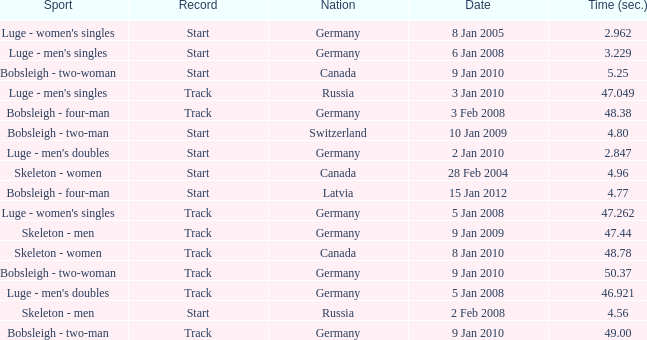Which sport has a time over 49? Bobsleigh - two-woman. 